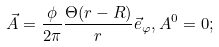<formula> <loc_0><loc_0><loc_500><loc_500>\vec { A } = \frac { \phi } { 2 \pi } \frac { \Theta ( r - R ) } { r } \vec { e } _ { \varphi } , A ^ { 0 } = 0 ;</formula> 